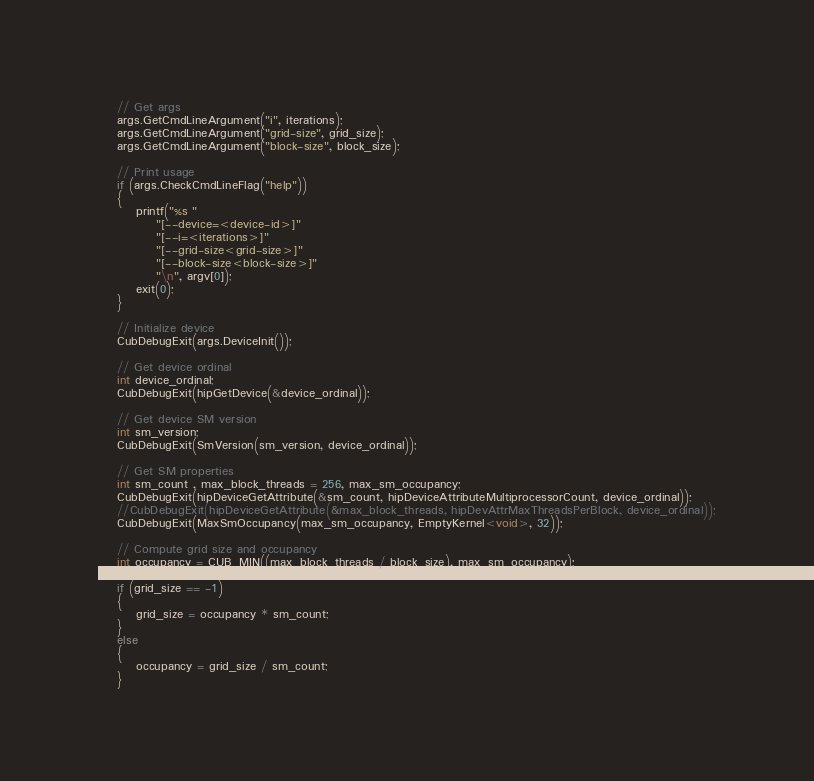Convert code to text. <code><loc_0><loc_0><loc_500><loc_500><_Cuda_>
    // Get args
    args.GetCmdLineArgument("i", iterations);
    args.GetCmdLineArgument("grid-size", grid_size);
    args.GetCmdLineArgument("block-size", block_size);

    // Print usage
    if (args.CheckCmdLineFlag("help"))
    {
        printf("%s "
            "[--device=<device-id>]"
            "[--i=<iterations>]"
            "[--grid-size<grid-size>]"
            "[--block-size<block-size>]"
            "\n", argv[0]);
        exit(0);
    }

    // Initialize device
    CubDebugExit(args.DeviceInit());

    // Get device ordinal
    int device_ordinal;
    CubDebugExit(hipGetDevice(&device_ordinal));

    // Get device SM version
    int sm_version;
    CubDebugExit(SmVersion(sm_version, device_ordinal));

    // Get SM properties
    int sm_count , max_block_threads = 256, max_sm_occupancy;
    CubDebugExit(hipDeviceGetAttribute(&sm_count, hipDeviceAttributeMultiprocessorCount, device_ordinal));
    //CubDebugExit(hipDeviceGetAttribute(&max_block_threads, hipDevAttrMaxThreadsPerBlock, device_ordinal));
    CubDebugExit(MaxSmOccupancy(max_sm_occupancy, EmptyKernel<void>, 32));

    // Compute grid size and occupancy
    int occupancy = CUB_MIN((max_block_threads / block_size), max_sm_occupancy);

    if (grid_size == -1)
    {
        grid_size = occupancy * sm_count;
    }
    else
    {
        occupancy = grid_size / sm_count;
    }
</code> 